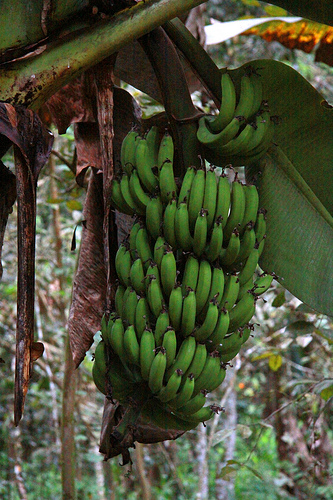Please provide the bounding box coordinate of the region this sentence describes: the leaf is dried. The coordinates of the dried leaf are [0.31, 0.32, 0.42, 0.56]. 